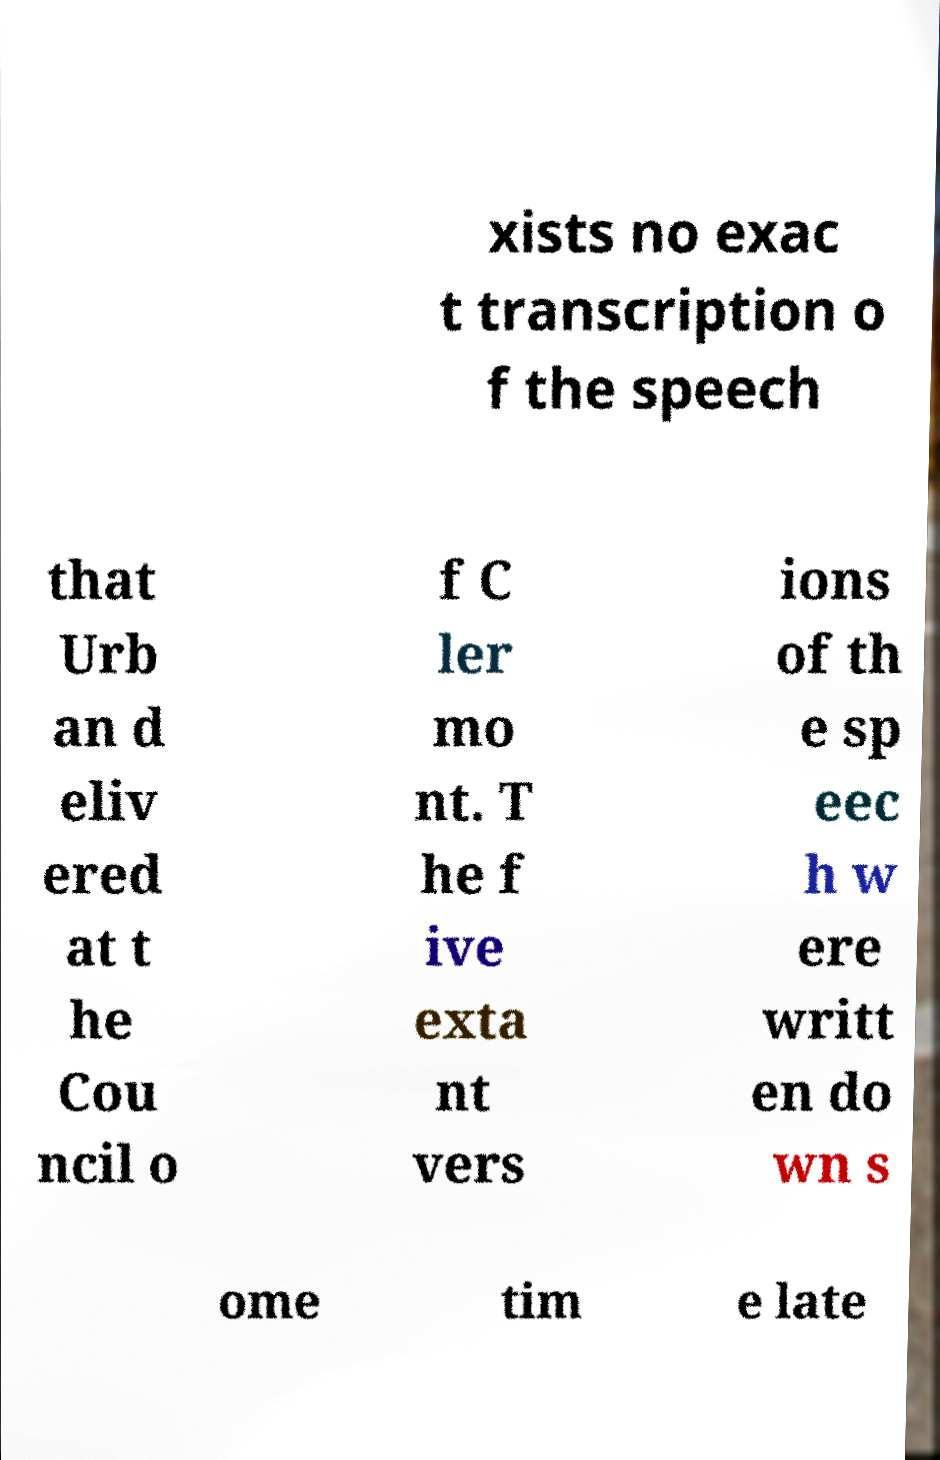Please identify and transcribe the text found in this image. xists no exac t transcription o f the speech that Urb an d eliv ered at t he Cou ncil o f C ler mo nt. T he f ive exta nt vers ions of th e sp eec h w ere writt en do wn s ome tim e late 